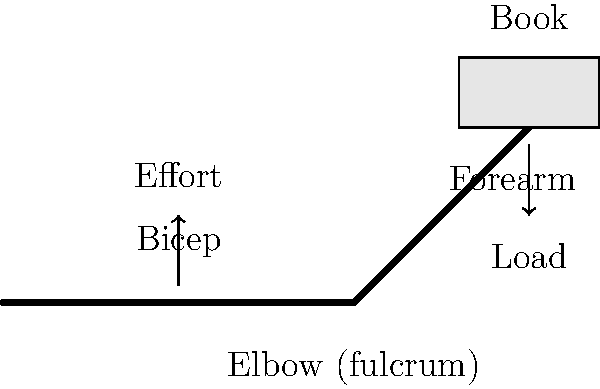When shelving a book, your arm acts as a lever system. Based on the illustration, which class of lever does the human arm represent in this action, and what is the mechanical advantage of this system? To determine the class of lever and its mechanical advantage, let's follow these steps:

1. Identify the components of the lever system:
   - Fulcrum: The elbow joint
   - Effort: Applied by the bicep muscle
   - Load: The weight of the book

2. Determine the arrangement of these components:
   The effort (bicep) is between the fulcrum (elbow) and the load (book). This arrangement characterizes a Class III lever.

3. Understand the characteristics of a Class III lever:
   - Always sacrifices force for range of motion
   - The effort arm is always shorter than the load arm
   - Mechanical advantage is always less than 1

4. Calculate the mechanical advantage:
   Mechanical Advantage (MA) = $\frac{\text{Load Arm}}{\text{Effort Arm}}$

   In the human arm:
   - Load Arm: Distance from elbow to hand (longer)
   - Effort Arm: Distance from elbow to bicep attachment (shorter)

   Therefore, $\text{MA} = \frac{\text{Longer distance}}{\text{Shorter distance}} < 1$

5. Interpret the result:
   A mechanical advantage less than 1 means more force must be applied by the bicep than the weight of the book, but it allows for a greater range of motion and speed.
Answer: Class III lever; Mechanical advantage < 1 